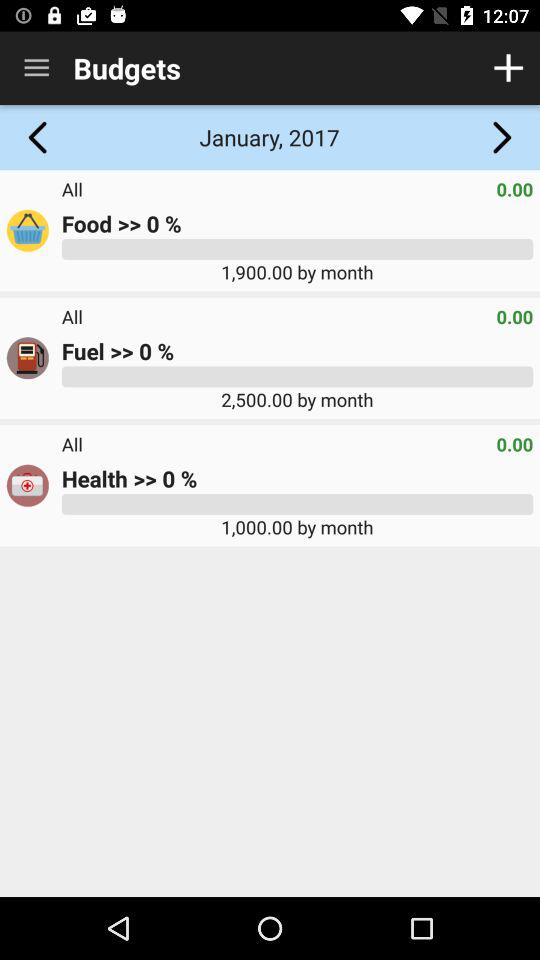What is the fuel budget for the month? The fuel budget for the month is 2,500. 